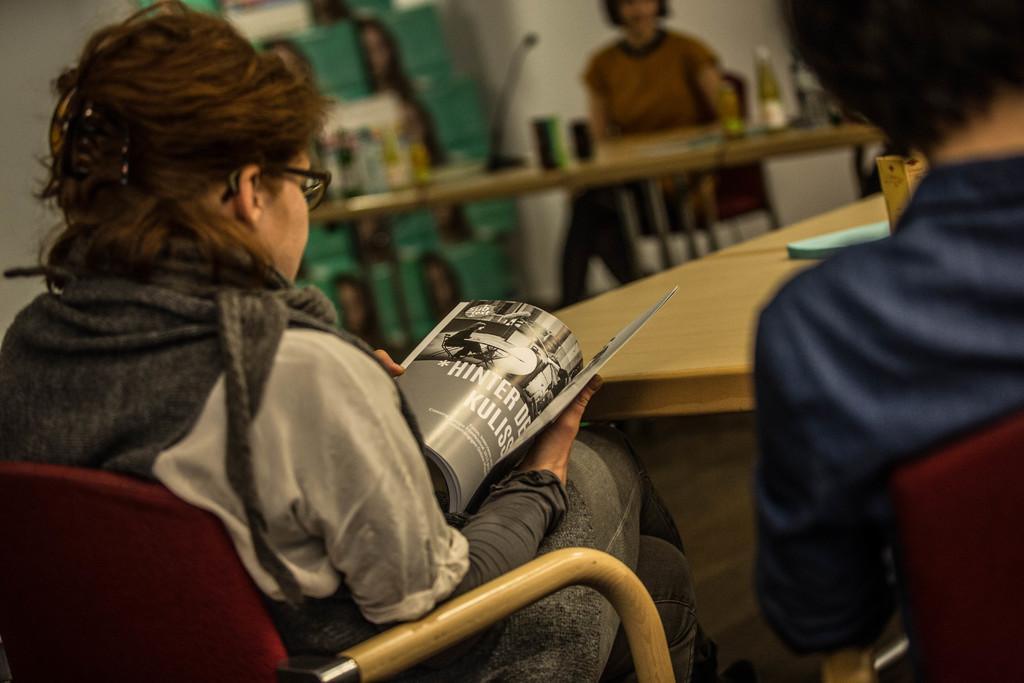Describe this image in one or two sentences. In this image we can see a woman sitting on a chair reading a book, beside the woman there is another person sitting on a chair, in front of them there is a table, in the background of the image there is another woman sitting on a chair, in front of the woman there is a table with a mic and some other objects on the table. 